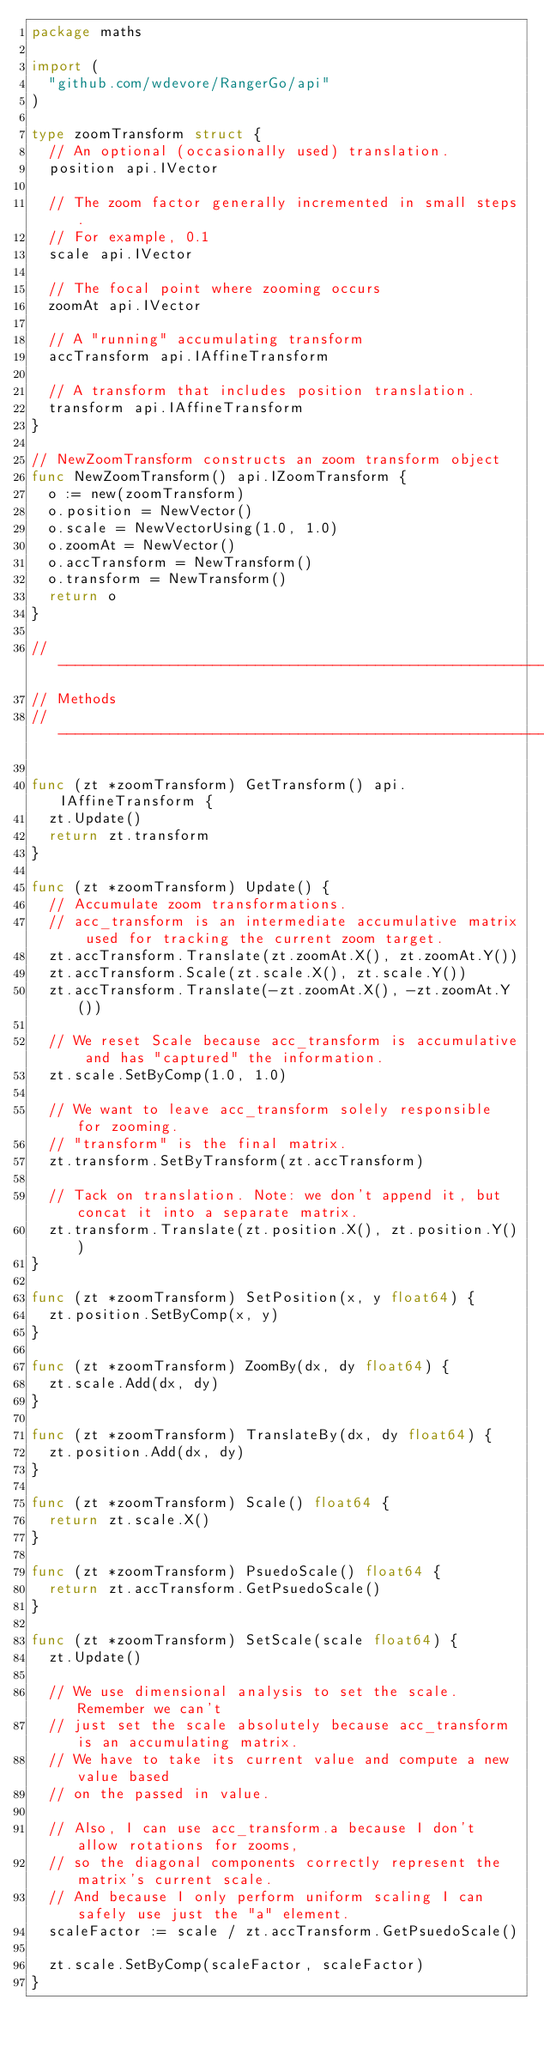<code> <loc_0><loc_0><loc_500><loc_500><_Go_>package maths

import (
	"github.com/wdevore/RangerGo/api"
)

type zoomTransform struct {
	// An optional (occasionally used) translation.
	position api.IVector

	// The zoom factor generally incremented in small steps.
	// For example, 0.1
	scale api.IVector

	// The focal point where zooming occurs
	zoomAt api.IVector

	// A "running" accumulating transform
	accTransform api.IAffineTransform

	// A transform that includes position translation.
	transform api.IAffineTransform
}

// NewZoomTransform constructs an zoom transform object
func NewZoomTransform() api.IZoomTransform {
	o := new(zoomTransform)
	o.position = NewVector()
	o.scale = NewVectorUsing(1.0, 1.0)
	o.zoomAt = NewVector()
	o.accTransform = NewTransform()
	o.transform = NewTransform()
	return o
}

// ----------------------------------------------------------
// Methods
// ----------------------------------------------------------

func (zt *zoomTransform) GetTransform() api.IAffineTransform {
	zt.Update()
	return zt.transform
}

func (zt *zoomTransform) Update() {
	// Accumulate zoom transformations.
	// acc_transform is an intermediate accumulative matrix used for tracking the current zoom target.
	zt.accTransform.Translate(zt.zoomAt.X(), zt.zoomAt.Y())
	zt.accTransform.Scale(zt.scale.X(), zt.scale.Y())
	zt.accTransform.Translate(-zt.zoomAt.X(), -zt.zoomAt.Y())

	// We reset Scale because acc_transform is accumulative and has "captured" the information.
	zt.scale.SetByComp(1.0, 1.0)

	// We want to leave acc_transform solely responsible for zooming.
	// "transform" is the final matrix.
	zt.transform.SetByTransform(zt.accTransform)

	// Tack on translation. Note: we don't append it, but concat it into a separate matrix.
	zt.transform.Translate(zt.position.X(), zt.position.Y())
}

func (zt *zoomTransform) SetPosition(x, y float64) {
	zt.position.SetByComp(x, y)
}

func (zt *zoomTransform) ZoomBy(dx, dy float64) {
	zt.scale.Add(dx, dy)
}

func (zt *zoomTransform) TranslateBy(dx, dy float64) {
	zt.position.Add(dx, dy)
}

func (zt *zoomTransform) Scale() float64 {
	return zt.scale.X()
}

func (zt *zoomTransform) PsuedoScale() float64 {
	return zt.accTransform.GetPsuedoScale()
}

func (zt *zoomTransform) SetScale(scale float64) {
	zt.Update()

	// We use dimensional analysis to set the scale. Remember we can't
	// just set the scale absolutely because acc_transform is an accumulating matrix.
	// We have to take its current value and compute a new value based
	// on the passed in value.

	// Also, I can use acc_transform.a because I don't allow rotations for zooms,
	// so the diagonal components correctly represent the matrix's current scale.
	// And because I only perform uniform scaling I can safely use just the "a" element.
	scaleFactor := scale / zt.accTransform.GetPsuedoScale()

	zt.scale.SetByComp(scaleFactor, scaleFactor)
}
</code> 